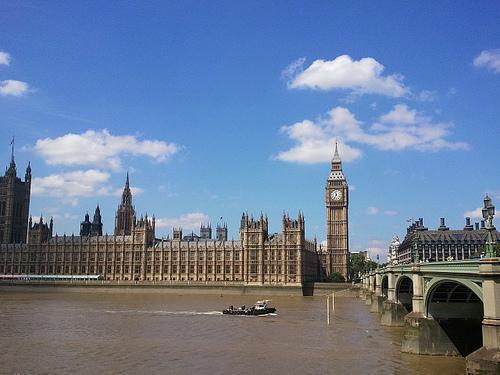How many boats are in the water?
Give a very brief answer. 1. 